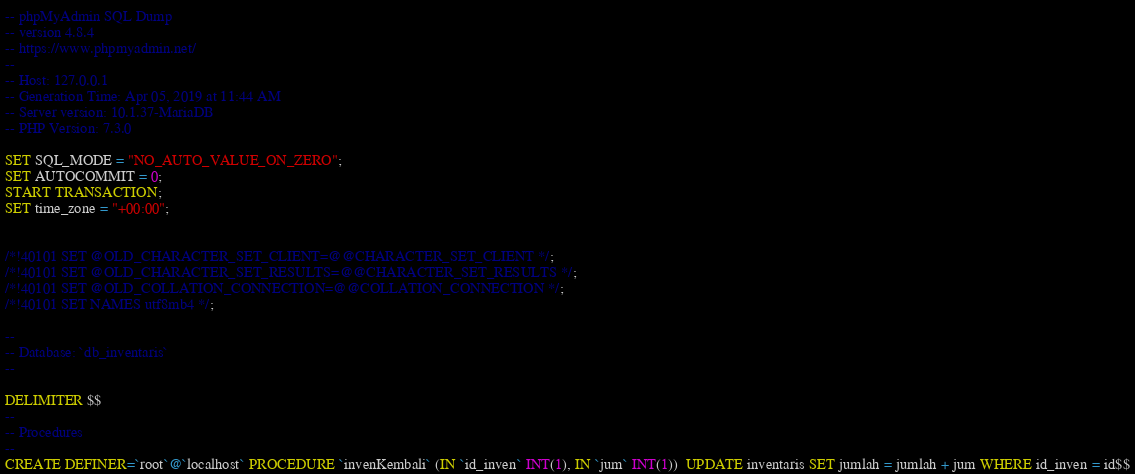Convert code to text. <code><loc_0><loc_0><loc_500><loc_500><_SQL_>-- phpMyAdmin SQL Dump
-- version 4.8.4
-- https://www.phpmyadmin.net/
--
-- Host: 127.0.0.1
-- Generation Time: Apr 05, 2019 at 11:44 AM
-- Server version: 10.1.37-MariaDB
-- PHP Version: 7.3.0

SET SQL_MODE = "NO_AUTO_VALUE_ON_ZERO";
SET AUTOCOMMIT = 0;
START TRANSACTION;
SET time_zone = "+00:00";


/*!40101 SET @OLD_CHARACTER_SET_CLIENT=@@CHARACTER_SET_CLIENT */;
/*!40101 SET @OLD_CHARACTER_SET_RESULTS=@@CHARACTER_SET_RESULTS */;
/*!40101 SET @OLD_COLLATION_CONNECTION=@@COLLATION_CONNECTION */;
/*!40101 SET NAMES utf8mb4 */;

--
-- Database: `db_inventaris`
--

DELIMITER $$
--
-- Procedures
--
CREATE DEFINER=`root`@`localhost` PROCEDURE `invenKembali` (IN `id_inven` INT(1), IN `jum` INT(1))  UPDATE inventaris SET jumlah = jumlah + jum WHERE id_inven = id$$
</code> 